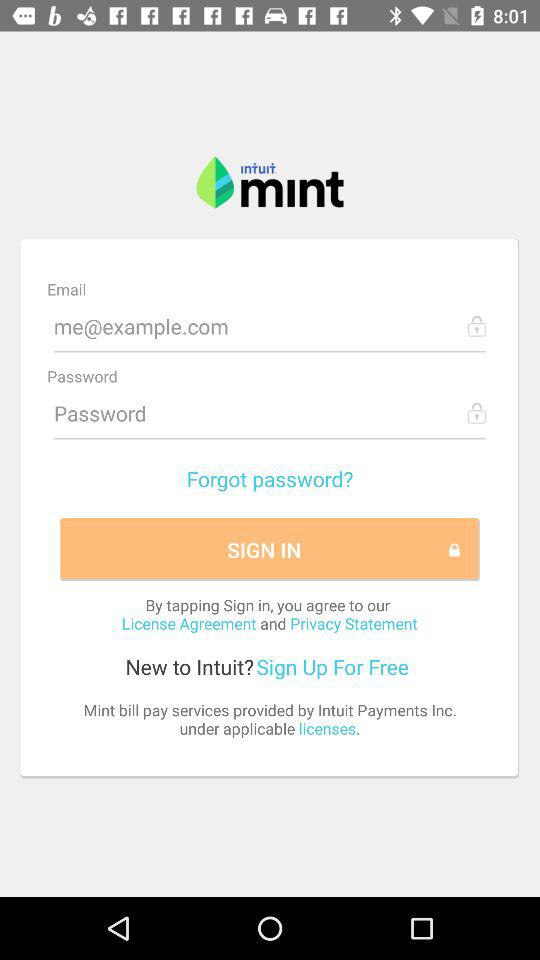What is the email address? The email address is me@example.com. 